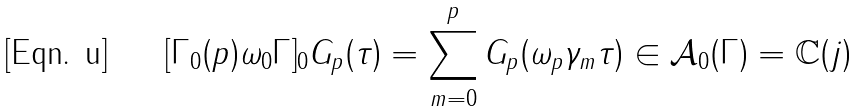<formula> <loc_0><loc_0><loc_500><loc_500>[ \Gamma _ { 0 } ( p ) \omega _ { 0 } \Gamma ] _ { 0 } G _ { p } ( \tau ) = \sum _ { m = 0 } ^ { p } G _ { p } ( \omega _ { p } \gamma _ { m } \tau ) \in { \mathcal { A } _ { 0 } ( \Gamma ) } = \mathbb { C } ( j )</formula> 